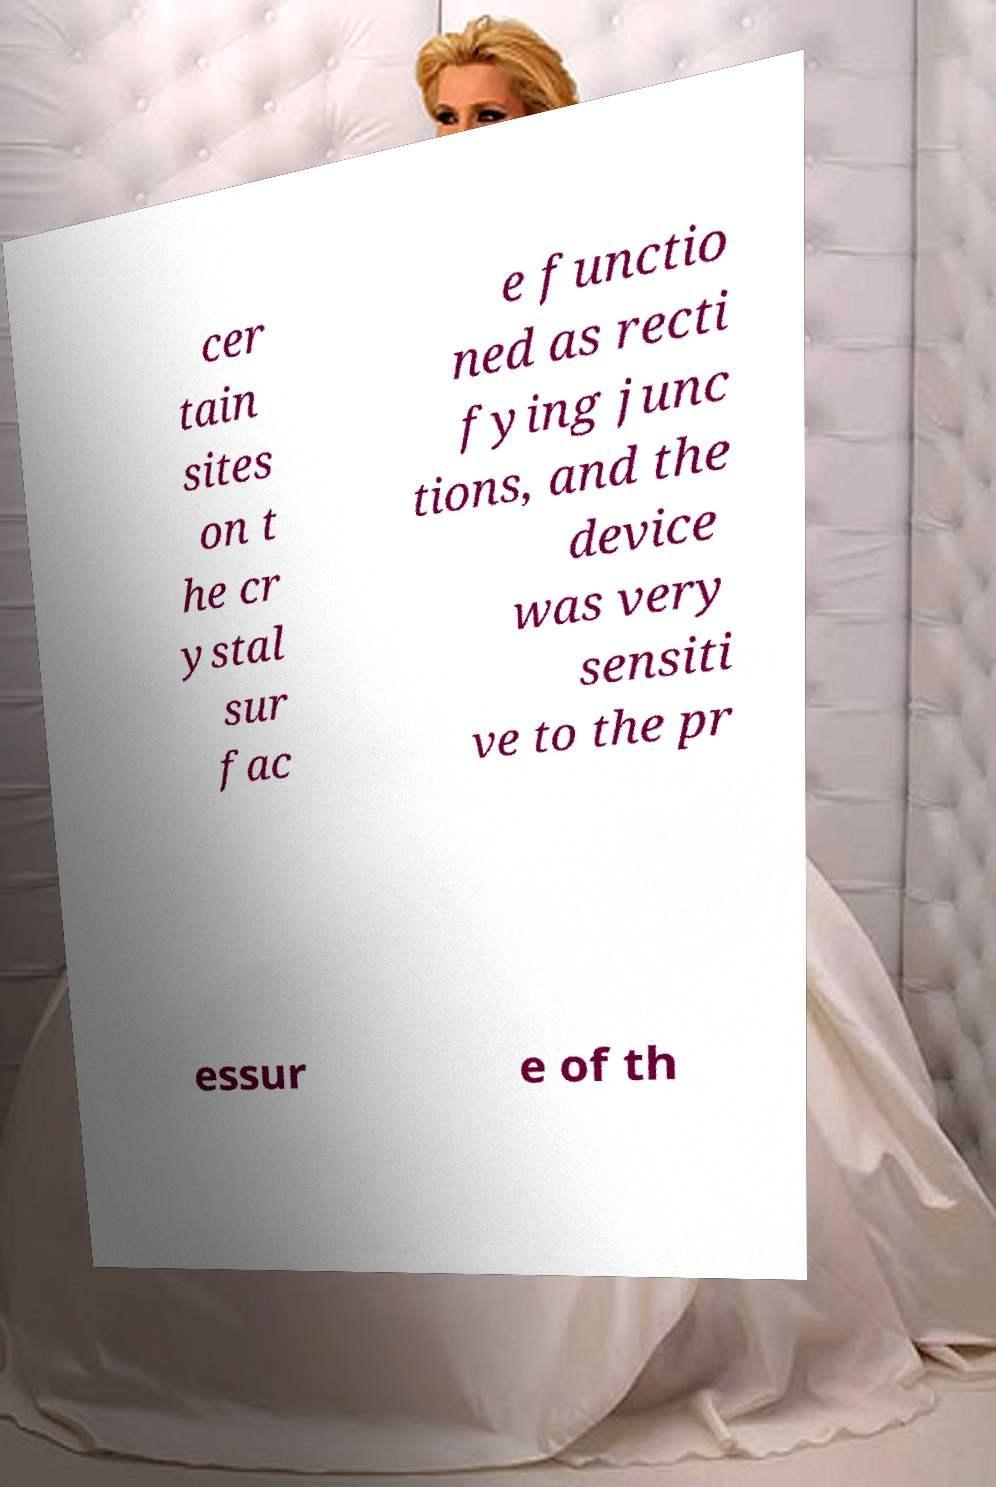I need the written content from this picture converted into text. Can you do that? cer tain sites on t he cr ystal sur fac e functio ned as recti fying junc tions, and the device was very sensiti ve to the pr essur e of th 